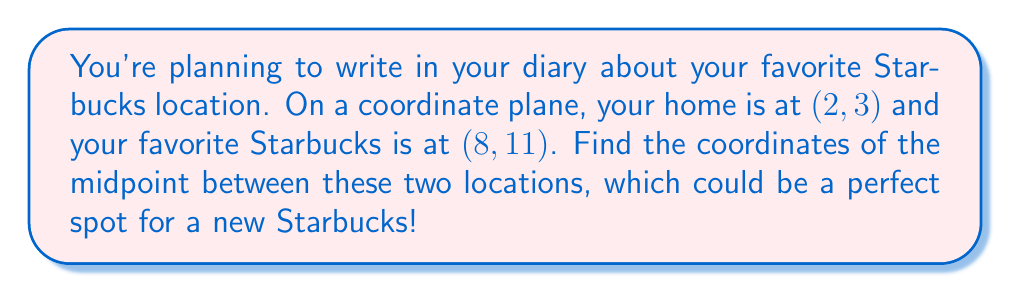What is the answer to this math problem? To find the midpoint between two points, we use the midpoint formula:

$$ \text{Midpoint} = \left(\frac{x_1 + x_2}{2}, \frac{y_1 + y_2}{2}\right) $$

Where $(x_1, y_1)$ is the first point and $(x_2, y_2)$ is the second point.

In this case:
- Your home is at $(x_1, y_1) = (2, 3)$
- Your favorite Starbucks is at $(x_2, y_2) = (8, 11)$

Let's substitute these values into the midpoint formula:

$$ \text{Midpoint} = \left(\frac{2 + 8}{2}, \frac{3 + 11}{2}\right) $$

Now, let's calculate each coordinate:

For the x-coordinate:
$$ \frac{2 + 8}{2} = \frac{10}{2} = 5 $$

For the y-coordinate:
$$ \frac{3 + 11}{2} = \frac{14}{2} = 7 $$

Therefore, the midpoint is at (5, 7).

[asy]
unitsize(1cm);
draw((-1,-1)--(10,13), gray);
draw((-1,13)--(10,-1), gray);
for(int i=-1; i<=10; ++i) {
  draw((i,-1)--(i,13), gray+0.5*opacity(0.5));
  draw((-1,i)--(10,i), gray+0.5*opacity(0.5));
}
dot((2,3), red);
dot((8,11), red);
dot((5,7), blue);
label("Home (2, 3)", (2,3), SW, red);
label("Starbucks (8, 11)", (8,11), NE, red);
label("Midpoint (5, 7)", (5,7), SE, blue);
[/asy]
Answer: The midpoint between your home and favorite Starbucks is (5, 7). 